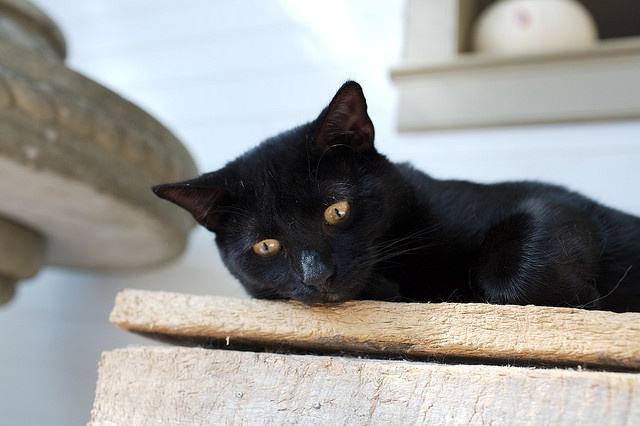Describe the objects in this image and their specific colors. I can see a cat in gray, black, and lightgray tones in this image. 